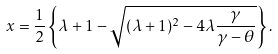Convert formula to latex. <formula><loc_0><loc_0><loc_500><loc_500>x = \frac { 1 } { 2 } \left \{ \lambda + 1 - \sqrt { ( \lambda + 1 ) ^ { 2 } - 4 \lambda \frac { \gamma } { \gamma - \theta } } \right \} .</formula> 